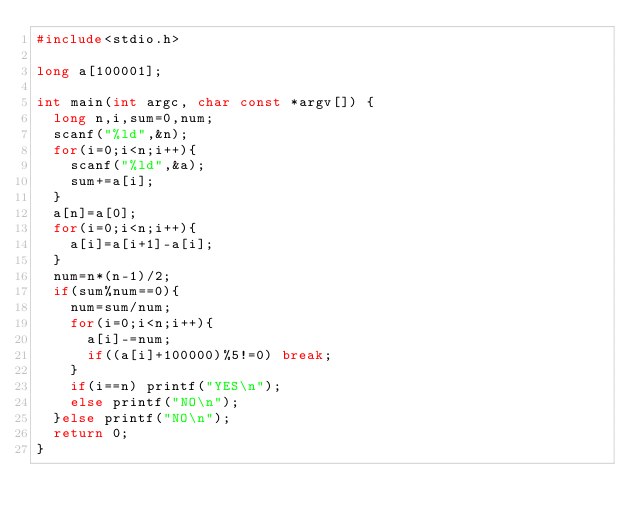Convert code to text. <code><loc_0><loc_0><loc_500><loc_500><_C_>#include<stdio.h>

long a[100001];

int main(int argc, char const *argv[]) {
	long n,i,sum=0,num;
	scanf("%ld",&n);
	for(i=0;i<n;i++){
		scanf("%ld",&a);
		sum+=a[i];
	}
	a[n]=a[0];
	for(i=0;i<n;i++){
		a[i]=a[i+1]-a[i];
	}
	num=n*(n-1)/2;
	if(sum%num==0){
		num=sum/num;
		for(i=0;i<n;i++){
			a[i]-=num;
			if((a[i]+100000)%5!=0) break;
		}
		if(i==n) printf("YES\n");
		else printf("NO\n");
	}else printf("NO\n");
	return 0;
}</code> 